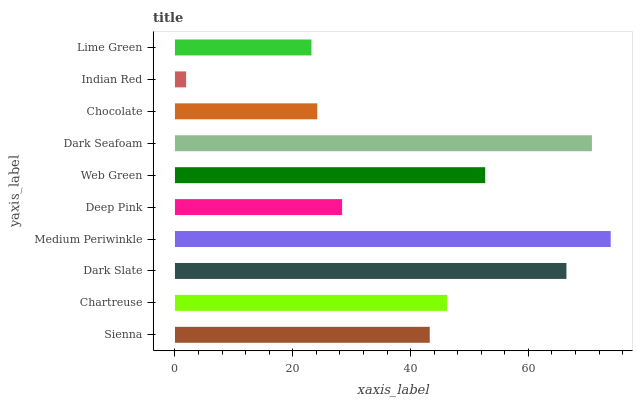Is Indian Red the minimum?
Answer yes or no. Yes. Is Medium Periwinkle the maximum?
Answer yes or no. Yes. Is Chartreuse the minimum?
Answer yes or no. No. Is Chartreuse the maximum?
Answer yes or no. No. Is Chartreuse greater than Sienna?
Answer yes or no. Yes. Is Sienna less than Chartreuse?
Answer yes or no. Yes. Is Sienna greater than Chartreuse?
Answer yes or no. No. Is Chartreuse less than Sienna?
Answer yes or no. No. Is Chartreuse the high median?
Answer yes or no. Yes. Is Sienna the low median?
Answer yes or no. Yes. Is Chocolate the high median?
Answer yes or no. No. Is Chocolate the low median?
Answer yes or no. No. 